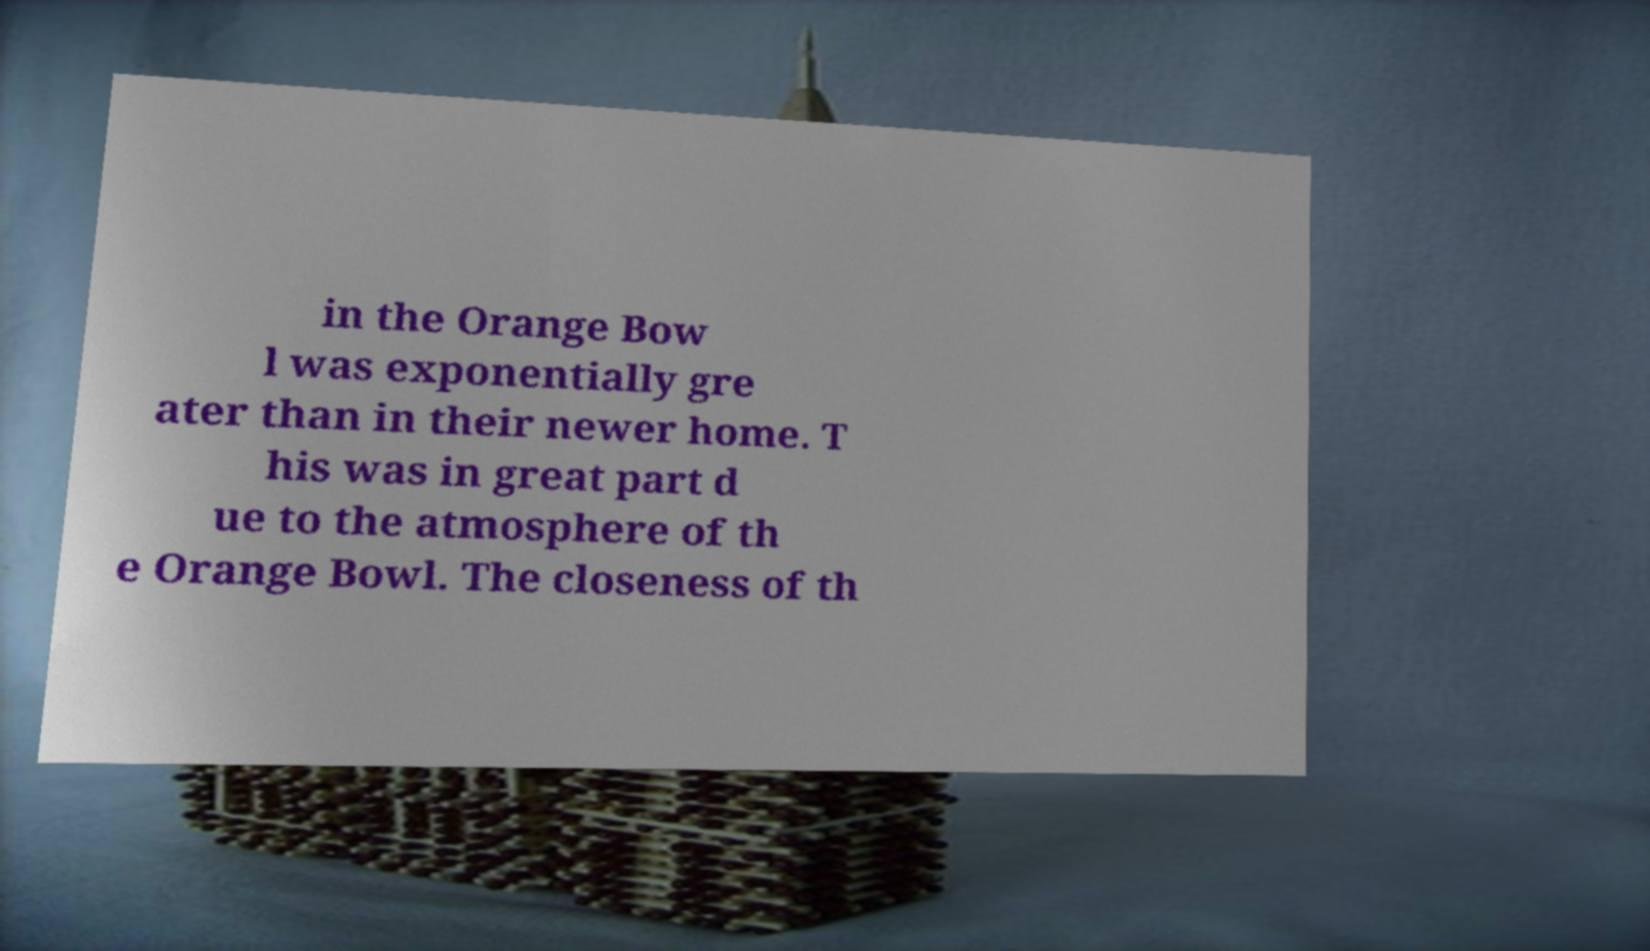Could you assist in decoding the text presented in this image and type it out clearly? in the Orange Bow l was exponentially gre ater than in their newer home. T his was in great part d ue to the atmosphere of th e Orange Bowl. The closeness of th 